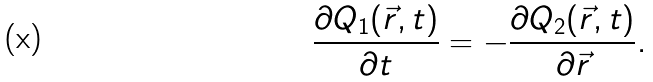Convert formula to latex. <formula><loc_0><loc_0><loc_500><loc_500>\frac { \partial Q _ { 1 } ( \vec { r } , t ) } { \partial t } = - \frac { \partial Q _ { 2 } ( \vec { r } , t ) } { \partial \vec { r } } .</formula> 